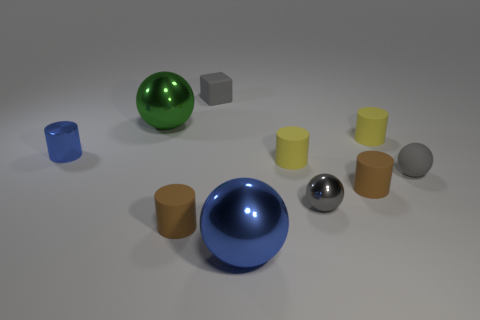There is a ball that is behind the matte sphere; is it the same color as the large metallic ball that is on the right side of the big green ball?
Give a very brief answer. No. What material is the other object that is the same size as the green object?
Make the answer very short. Metal. The blue thing that is behind the blue shiny thing that is in front of the brown cylinder on the right side of the matte cube is what shape?
Offer a very short reply. Cylinder. There is a blue thing that is the same size as the gray cube; what shape is it?
Ensure brevity in your answer.  Cylinder. How many blue shiny things are to the left of the small brown object to the left of the large shiny ball on the right side of the green shiny sphere?
Offer a very short reply. 1. Are there more small gray metallic balls in front of the gray metal object than tiny gray metal balls that are right of the tiny blue shiny cylinder?
Give a very brief answer. No. What number of small rubber objects have the same shape as the gray metallic thing?
Make the answer very short. 1. How many things are metallic spheres in front of the green metallic sphere or tiny brown rubber things that are left of the big blue metal ball?
Keep it short and to the point. 3. What is the material of the large sphere in front of the tiny brown rubber object that is left of the tiny metallic thing that is on the right side of the big blue shiny object?
Your answer should be compact. Metal. There is a tiny ball behind the gray metal thing; is it the same color as the tiny block?
Provide a short and direct response. Yes. 